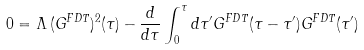<formula> <loc_0><loc_0><loc_500><loc_500>0 = \Lambda \, ( G ^ { F D T } ) ^ { 2 } ( \tau ) - \frac { d } { d \tau } \int _ { 0 } ^ { \tau } d \tau ^ { \prime } G ^ { F D T } ( \tau - \tau ^ { \prime } ) G ^ { F D T } ( \tau ^ { \prime } )</formula> 